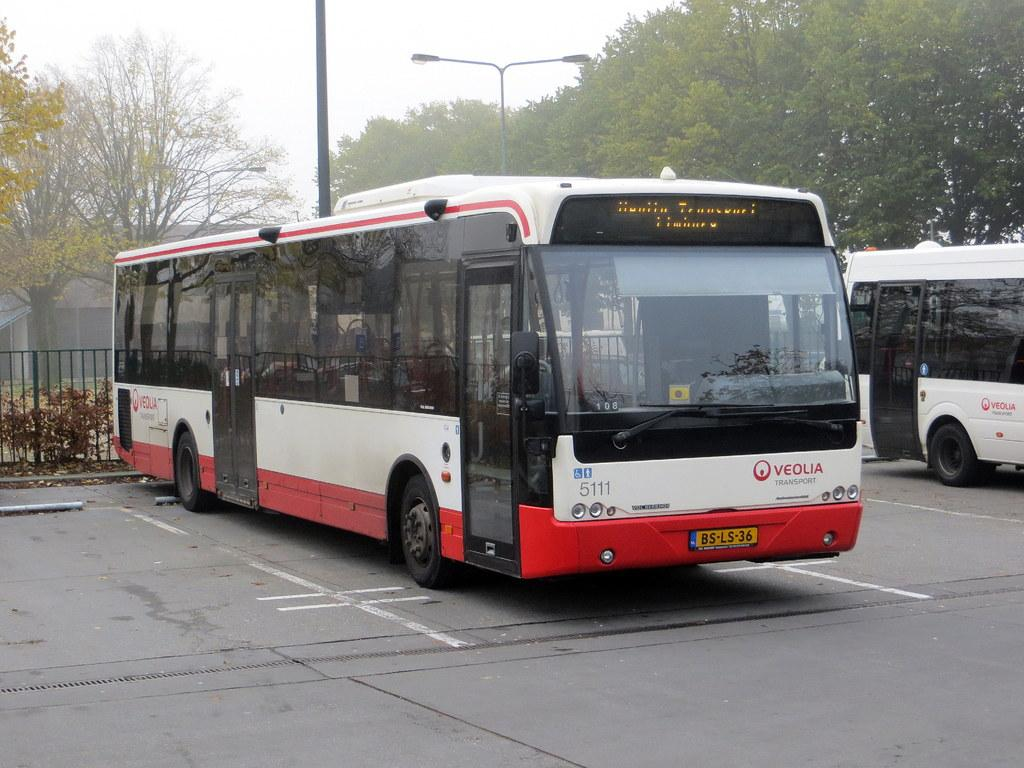Provide a one-sentence caption for the provided image. A bus from Veolia Transport sits in a parking spot. 